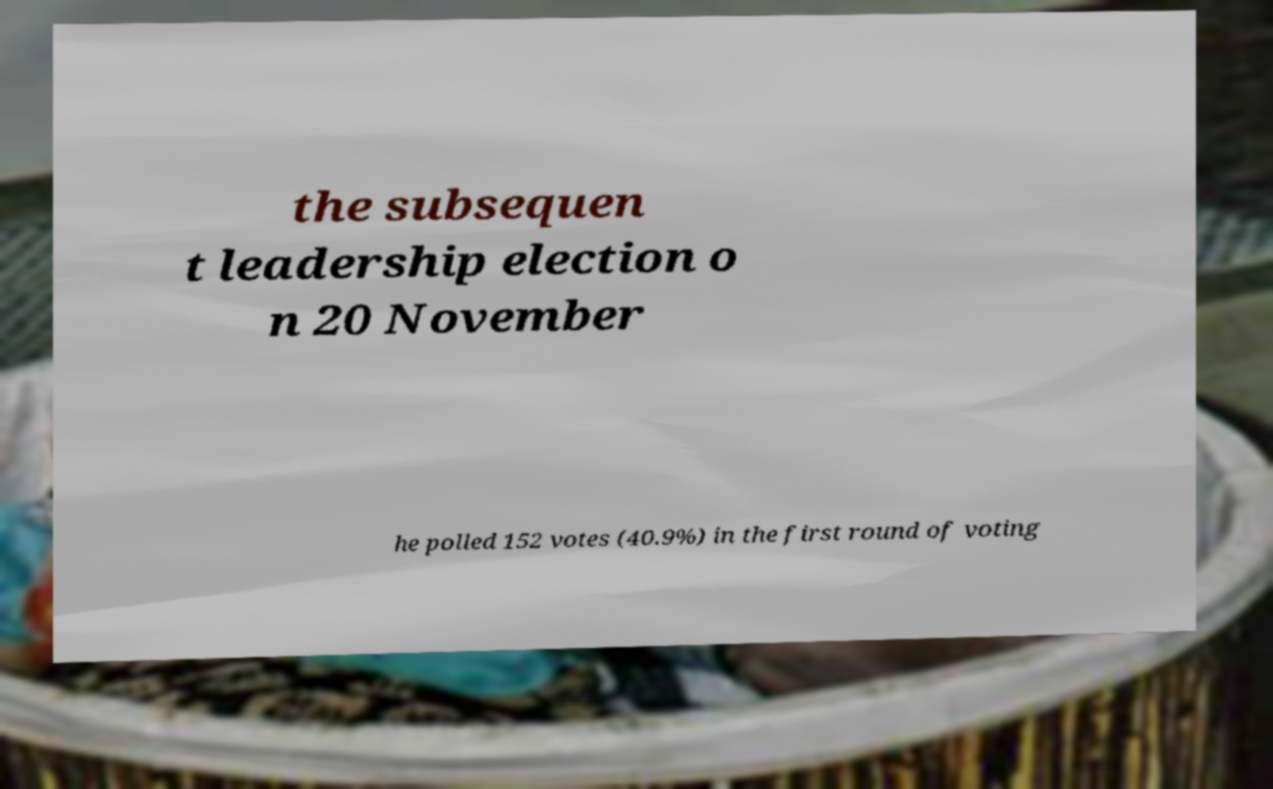Can you read and provide the text displayed in the image?This photo seems to have some interesting text. Can you extract and type it out for me? the subsequen t leadership election o n 20 November he polled 152 votes (40.9%) in the first round of voting 